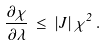<formula> <loc_0><loc_0><loc_500><loc_500>\frac { \partial \chi } { \partial \lambda } \, \leq \, | J | \, \chi ^ { 2 } \, .</formula> 